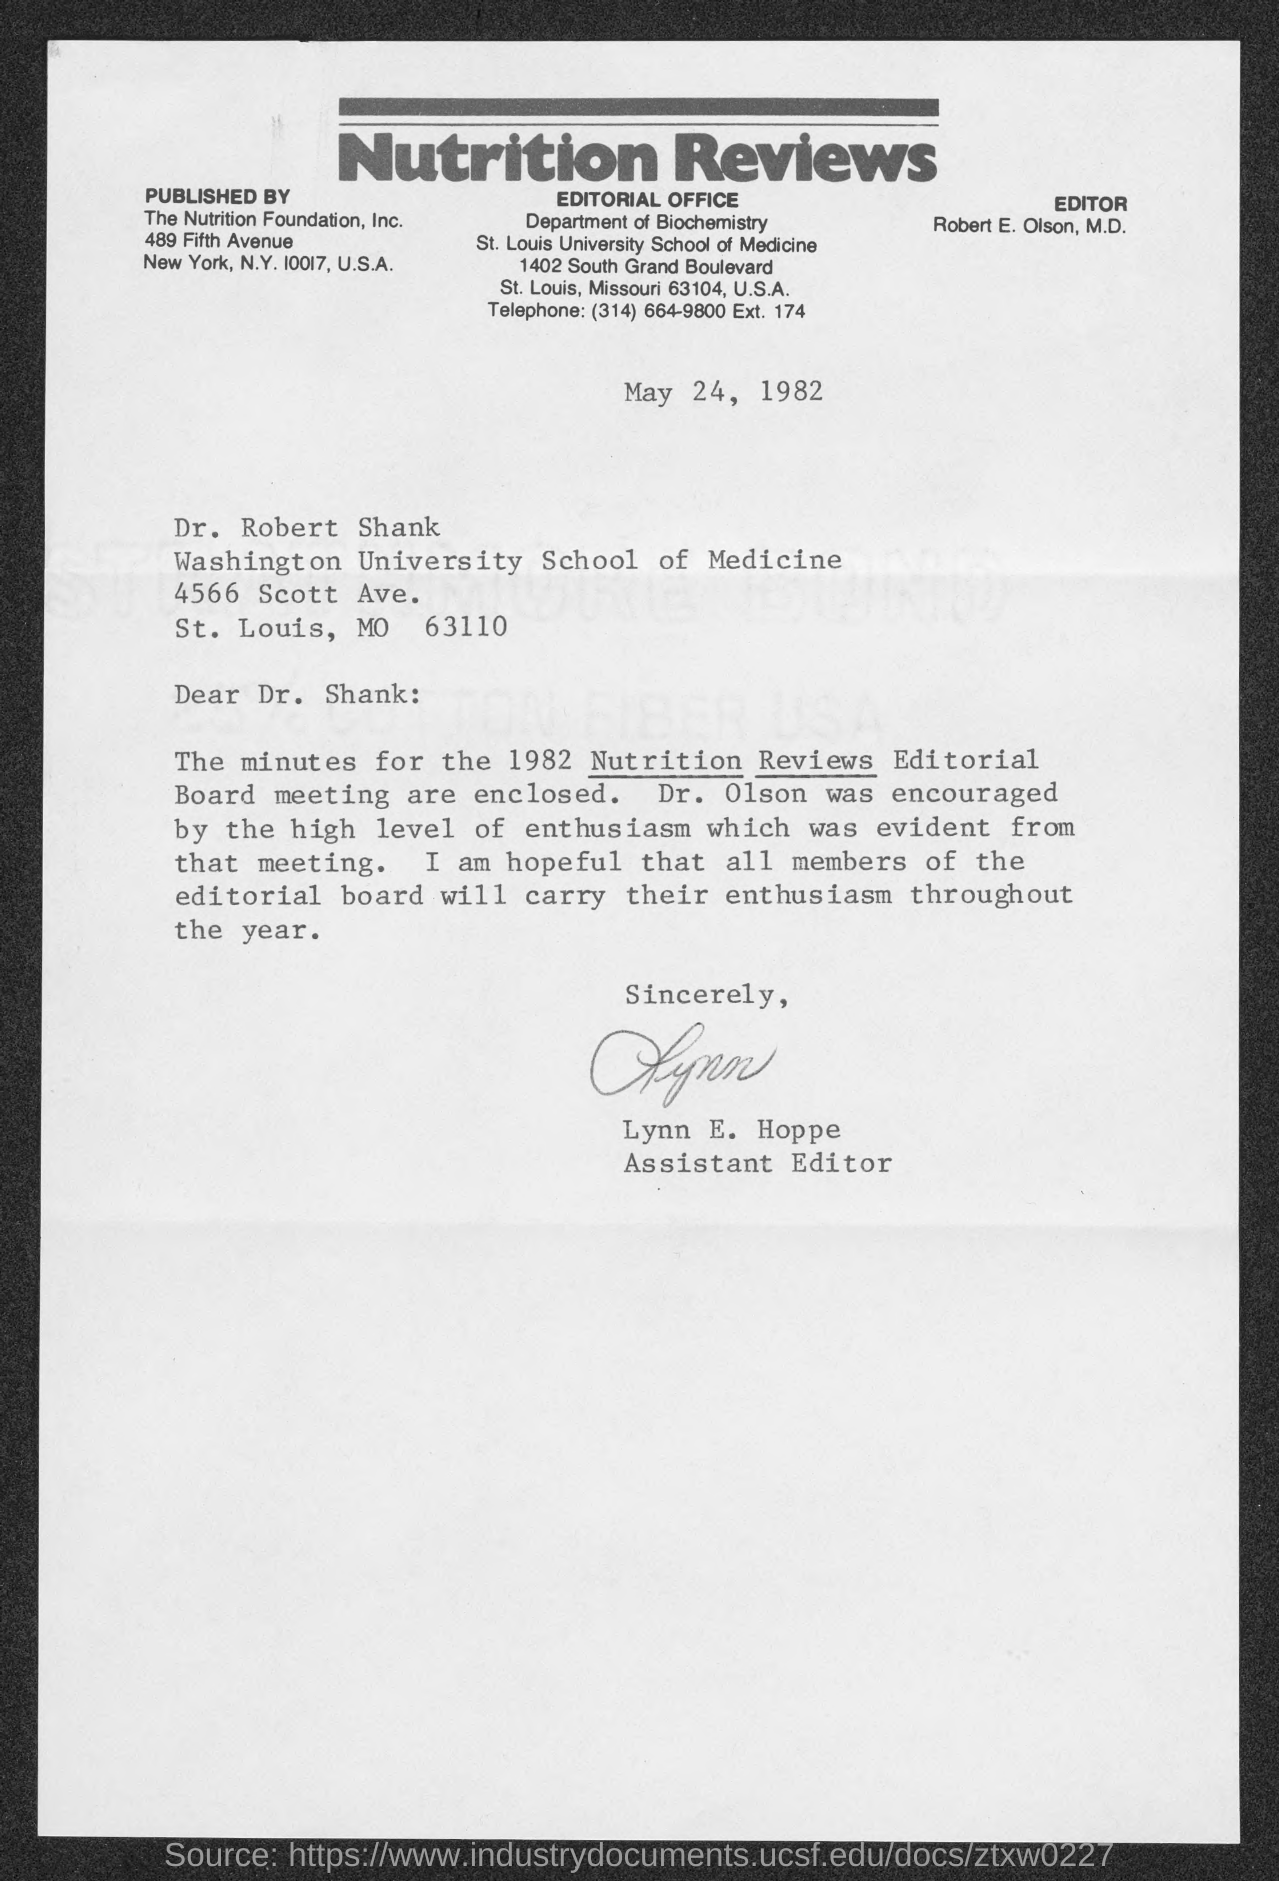What is the date mentioned in letter?
Your answer should be very brief. May 24, 1982. Who wrote this letter
Keep it short and to the point. Lynn e. hoppe. 